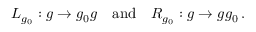Convert formula to latex. <formula><loc_0><loc_0><loc_500><loc_500>L _ { g _ { 0 } } \colon g \rightarrow g _ { 0 } g \quad a n d \quad R _ { g _ { 0 } } \colon g \rightarrow g g _ { 0 } \, .</formula> 